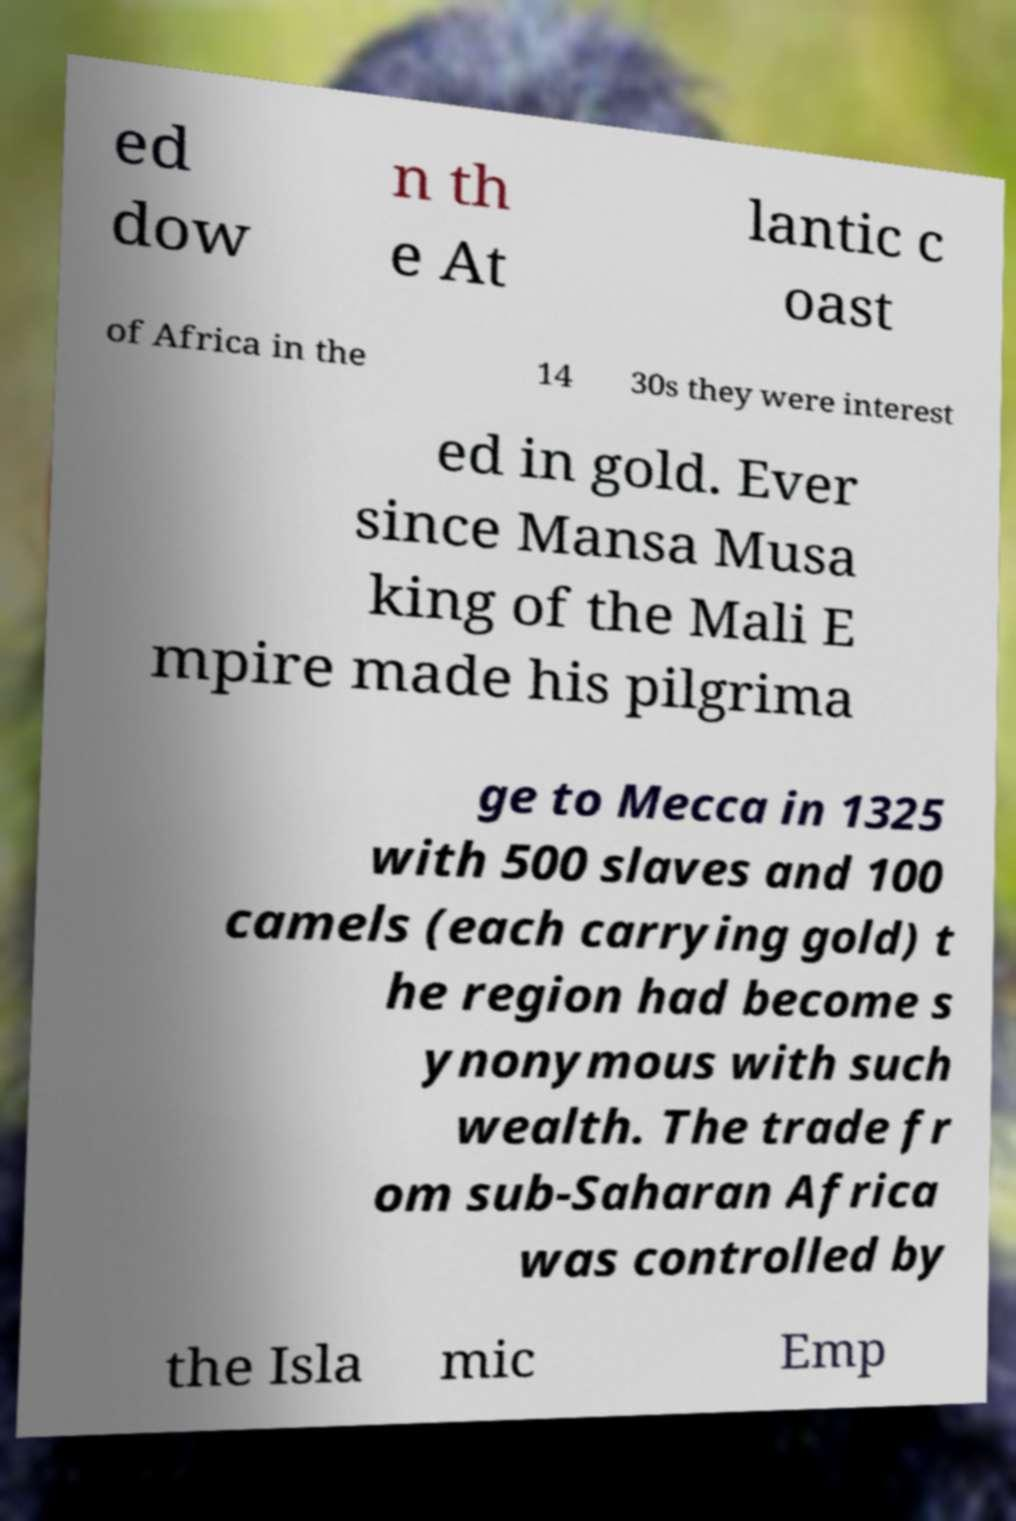There's text embedded in this image that I need extracted. Can you transcribe it verbatim? ed dow n th e At lantic c oast of Africa in the 14 30s they were interest ed in gold. Ever since Mansa Musa king of the Mali E mpire made his pilgrima ge to Mecca in 1325 with 500 slaves and 100 camels (each carrying gold) t he region had become s ynonymous with such wealth. The trade fr om sub-Saharan Africa was controlled by the Isla mic Emp 